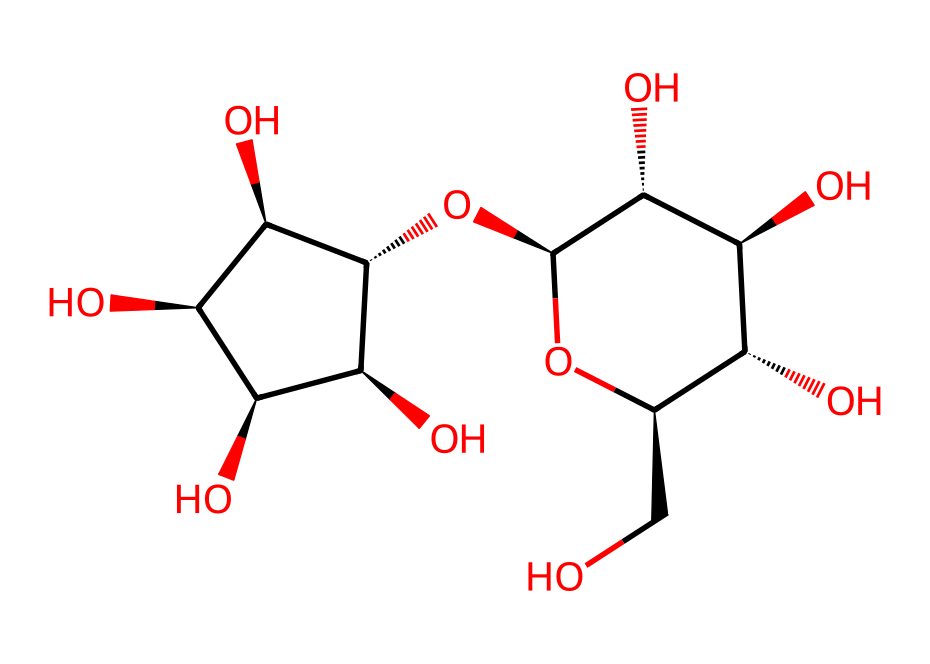What is the primary component of cotton fibers? The structure displayed represents cellulose, which is known to be the main constituent of cotton fibers.
Answer: cellulose How many carbon atoms are in the molecular structure? By analyzing the SMILES notation, we count the carbon atoms denoted by "C" in the structure. There are 6 carbon atoms in the repeating units, and considering the glycosidic linkages, the total number of carbon atoms is adjusted to 12.
Answer: twelve What type of polymer is cellulose? Cellulose is a polysaccharide, which indicates that it is a polymer made up of many sugar molecules (glucose units) linked together.
Answer: polysaccharide What functional groups are present in cellulose? The structure contains hydroxyl (-OH) groups, which are indicative of alcohols, contributing to the solubility and reactivity of cellulose.
Answer: hydroxyl groups Explain how the branching of cellulose impacts its properties. Cellulose consists of linear chains of glucose units that are interconnected through beta (1→4) glycosidic bonds, leading to a fibrous structure with little to no branching. This linearity contributes to its tensile strength and insolubility, making cellulose an excellent structural material.
Answer: linear structure How does the arrangement of glucose units affect the digestibility of cellulose? The arrangement involves beta linkages that humans cannot digest due to the lack of specific enzymes. These linkages create a tight structure that is not easily broken down, resulting in cellulose being indigestible by human enzymes compared to other forms of carbohydrates.
Answer: indigestible 